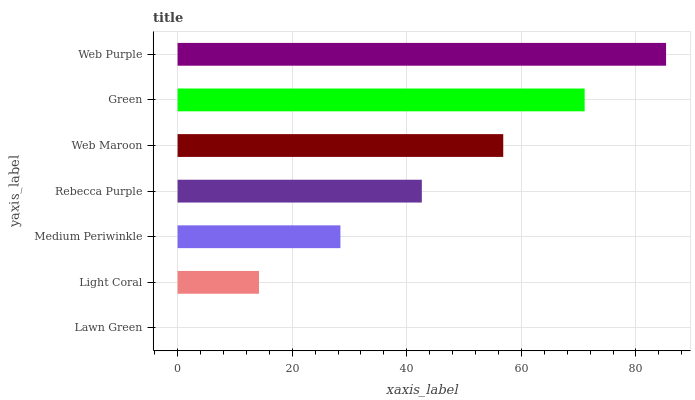Is Lawn Green the minimum?
Answer yes or no. Yes. Is Web Purple the maximum?
Answer yes or no. Yes. Is Light Coral the minimum?
Answer yes or no. No. Is Light Coral the maximum?
Answer yes or no. No. Is Light Coral greater than Lawn Green?
Answer yes or no. Yes. Is Lawn Green less than Light Coral?
Answer yes or no. Yes. Is Lawn Green greater than Light Coral?
Answer yes or no. No. Is Light Coral less than Lawn Green?
Answer yes or no. No. Is Rebecca Purple the high median?
Answer yes or no. Yes. Is Rebecca Purple the low median?
Answer yes or no. Yes. Is Lawn Green the high median?
Answer yes or no. No. Is Medium Periwinkle the low median?
Answer yes or no. No. 